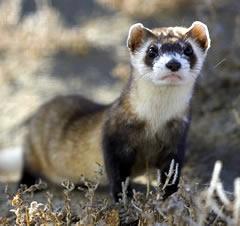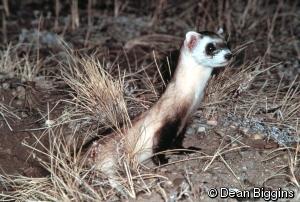The first image is the image on the left, the second image is the image on the right. Evaluate the accuracy of this statement regarding the images: "Every image in the set contains a single ferret, in an outdoor setting.". Is it true? Answer yes or no. Yes. The first image is the image on the left, the second image is the image on the right. Given the left and right images, does the statement "There are exactly two ferrets outdoors." hold true? Answer yes or no. Yes. 